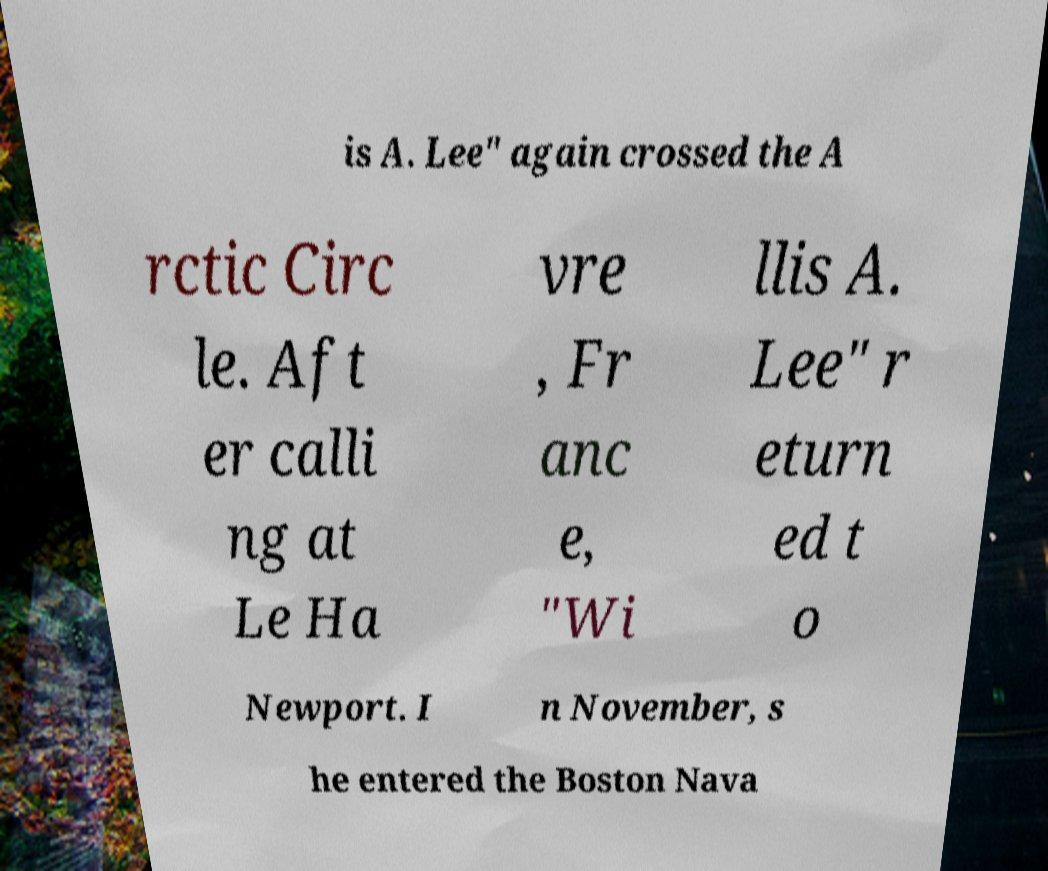There's text embedded in this image that I need extracted. Can you transcribe it verbatim? is A. Lee" again crossed the A rctic Circ le. Aft er calli ng at Le Ha vre , Fr anc e, "Wi llis A. Lee" r eturn ed t o Newport. I n November, s he entered the Boston Nava 